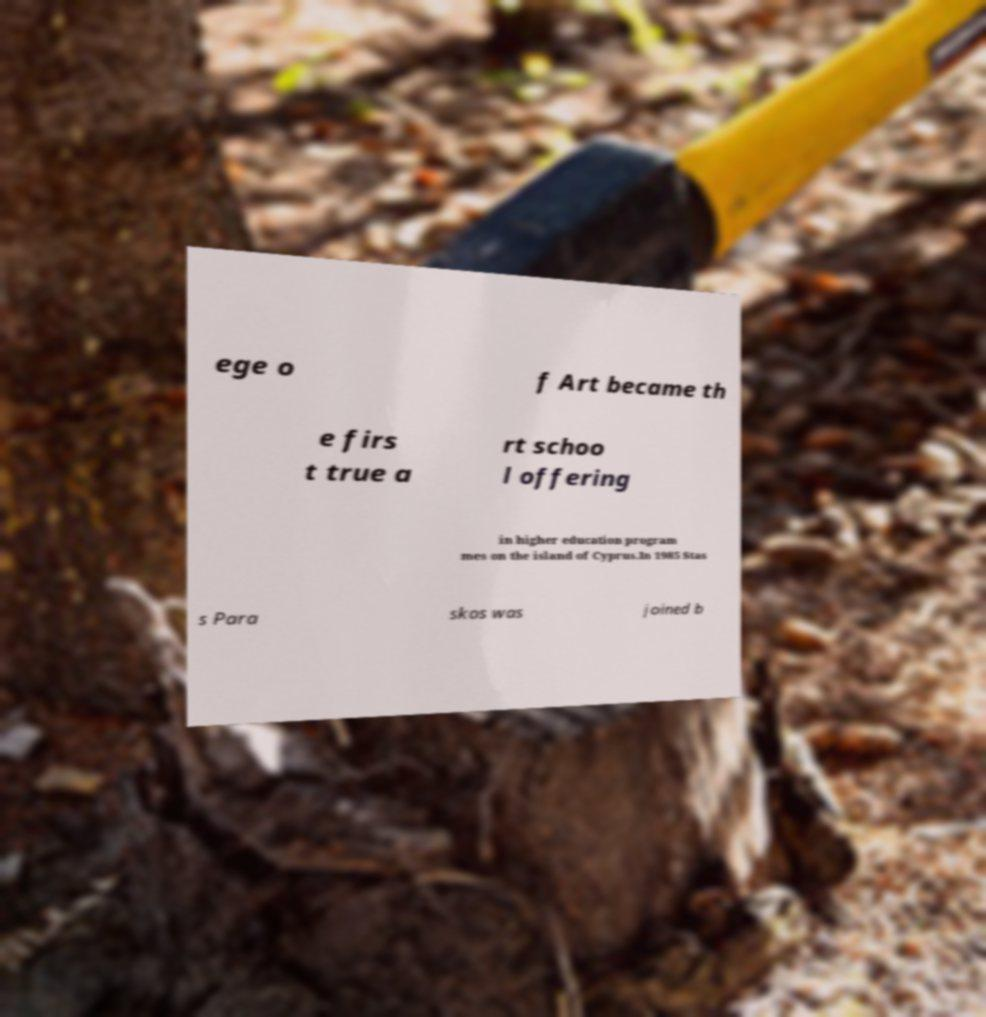There's text embedded in this image that I need extracted. Can you transcribe it verbatim? ege o f Art became th e firs t true a rt schoo l offering in higher education program mes on the island of Cyprus.In 1985 Stas s Para skos was joined b 